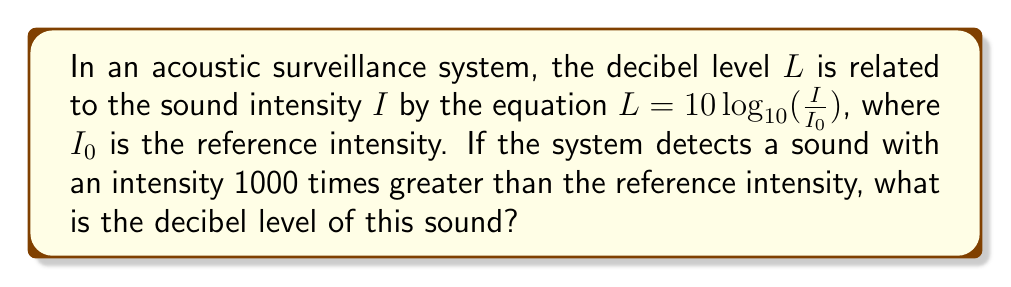Solve this math problem. Let's approach this step-by-step:

1) We are given the equation: $L = 10 \log_{10}(\frac{I}{I_0})$

2) We are told that the detected sound has an intensity 1000 times greater than the reference intensity. This means:

   $\frac{I}{I_0} = 1000$

3) Let's substitute this into our equation:

   $L = 10 \log_{10}(1000)$

4) Now, we need to evaluate $\log_{10}(1000)$:
   
   $1000 = 10^3$, so $\log_{10}(1000) = 3$

5) Substituting this back:

   $L = 10 \cdot 3 = 30$

Therefore, the decibel level of the detected sound is 30 dB.
Answer: 30 dB 